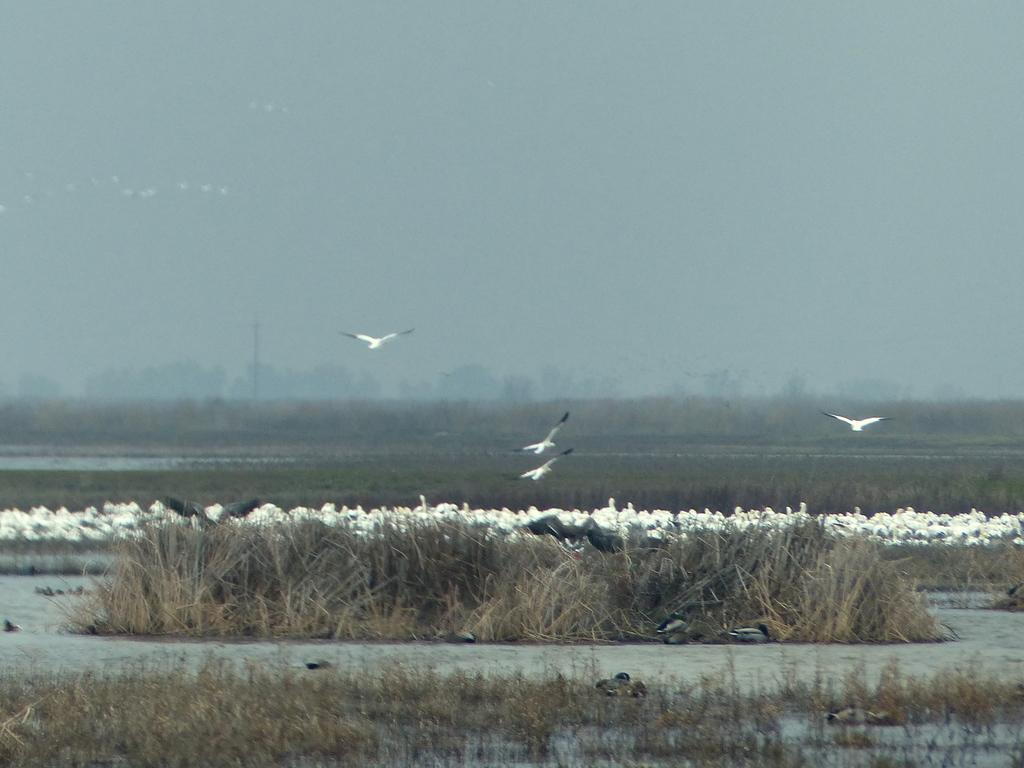What type of animals can be seen in the image? There are white-colored birds in the image. Where are the birds located in the image? The birds are in the water. What type of vegetation is visible in the image? There are trees in the image. What is visible at the top of the image? The sky is visible at the top of the image. What type of end is visible in the image? There is no end visible in the image. The image features white-colored birds in the water, trees, and the sky. 